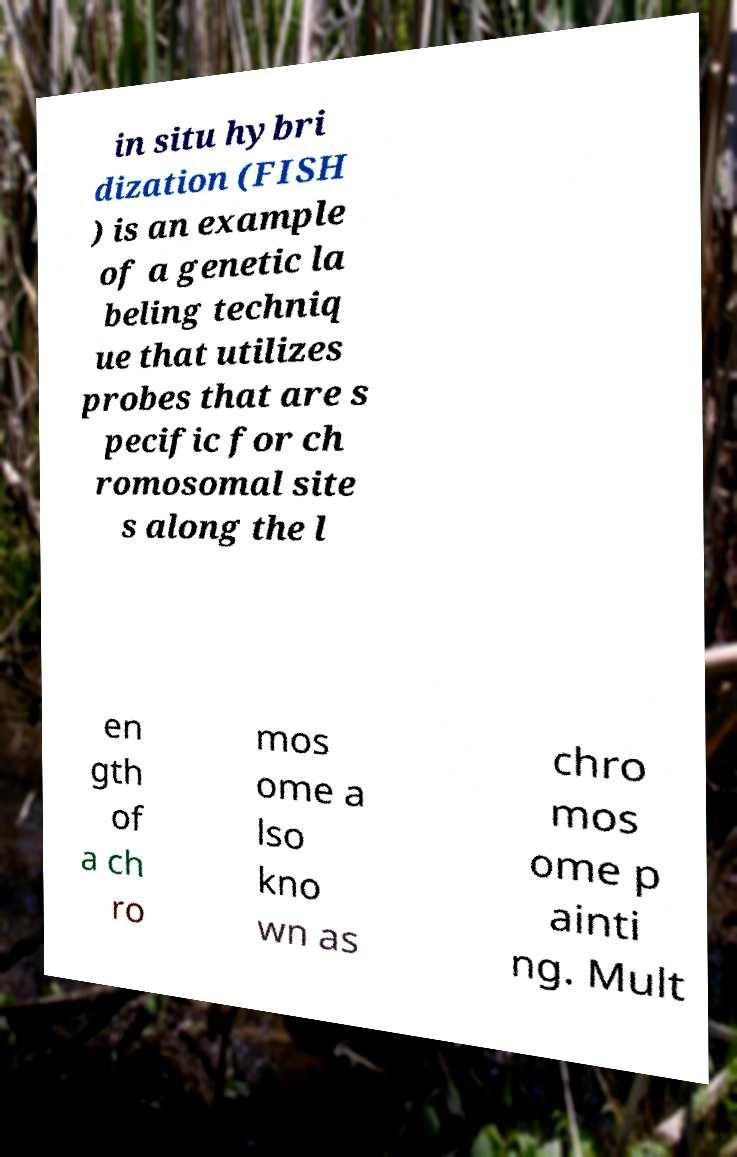Can you accurately transcribe the text from the provided image for me? in situ hybri dization (FISH ) is an example of a genetic la beling techniq ue that utilizes probes that are s pecific for ch romosomal site s along the l en gth of a ch ro mos ome a lso kno wn as chro mos ome p ainti ng. Mult 